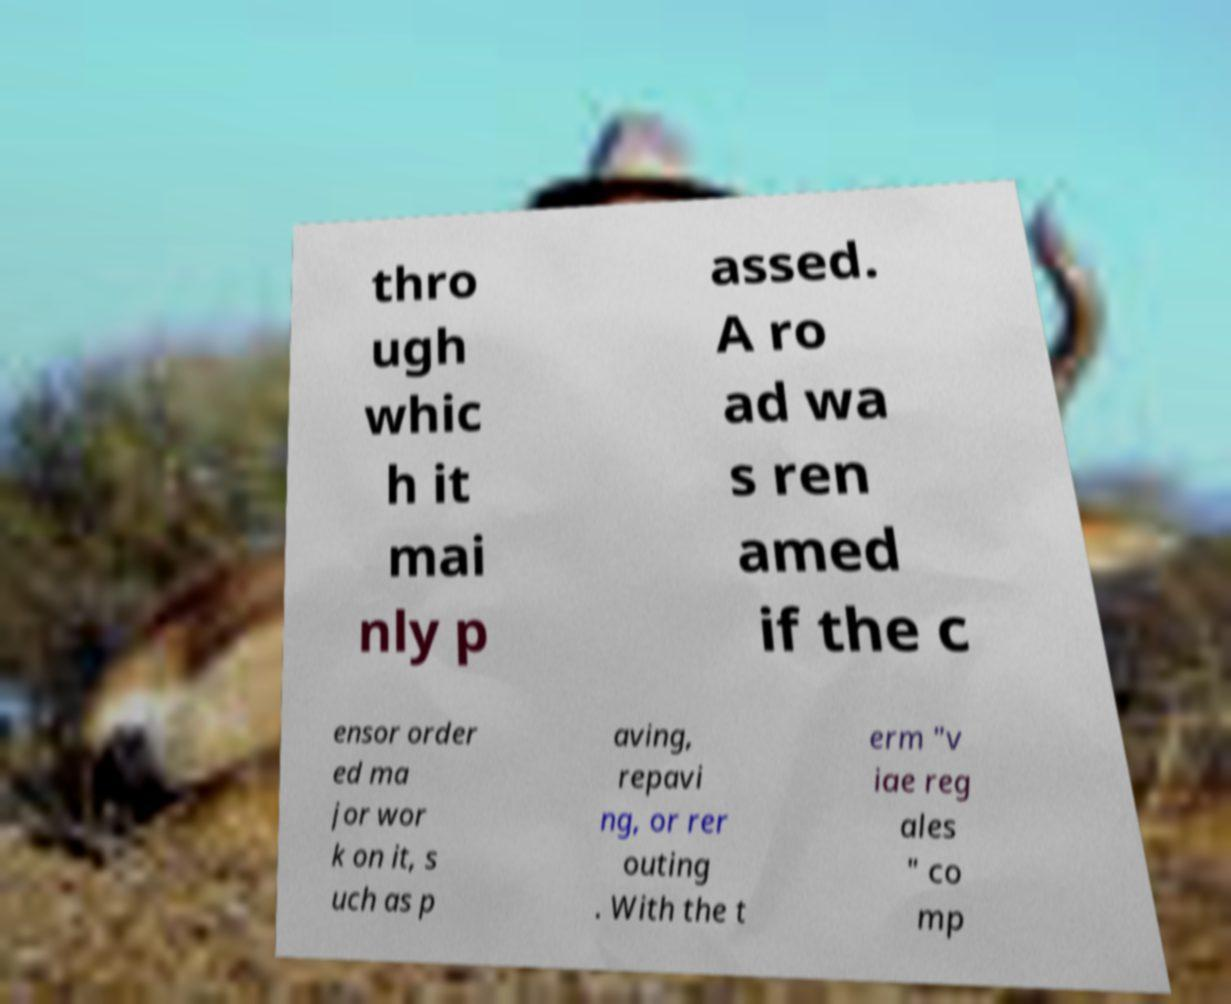Can you accurately transcribe the text from the provided image for me? thro ugh whic h it mai nly p assed. A ro ad wa s ren amed if the c ensor order ed ma jor wor k on it, s uch as p aving, repavi ng, or rer outing . With the t erm "v iae reg ales " co mp 